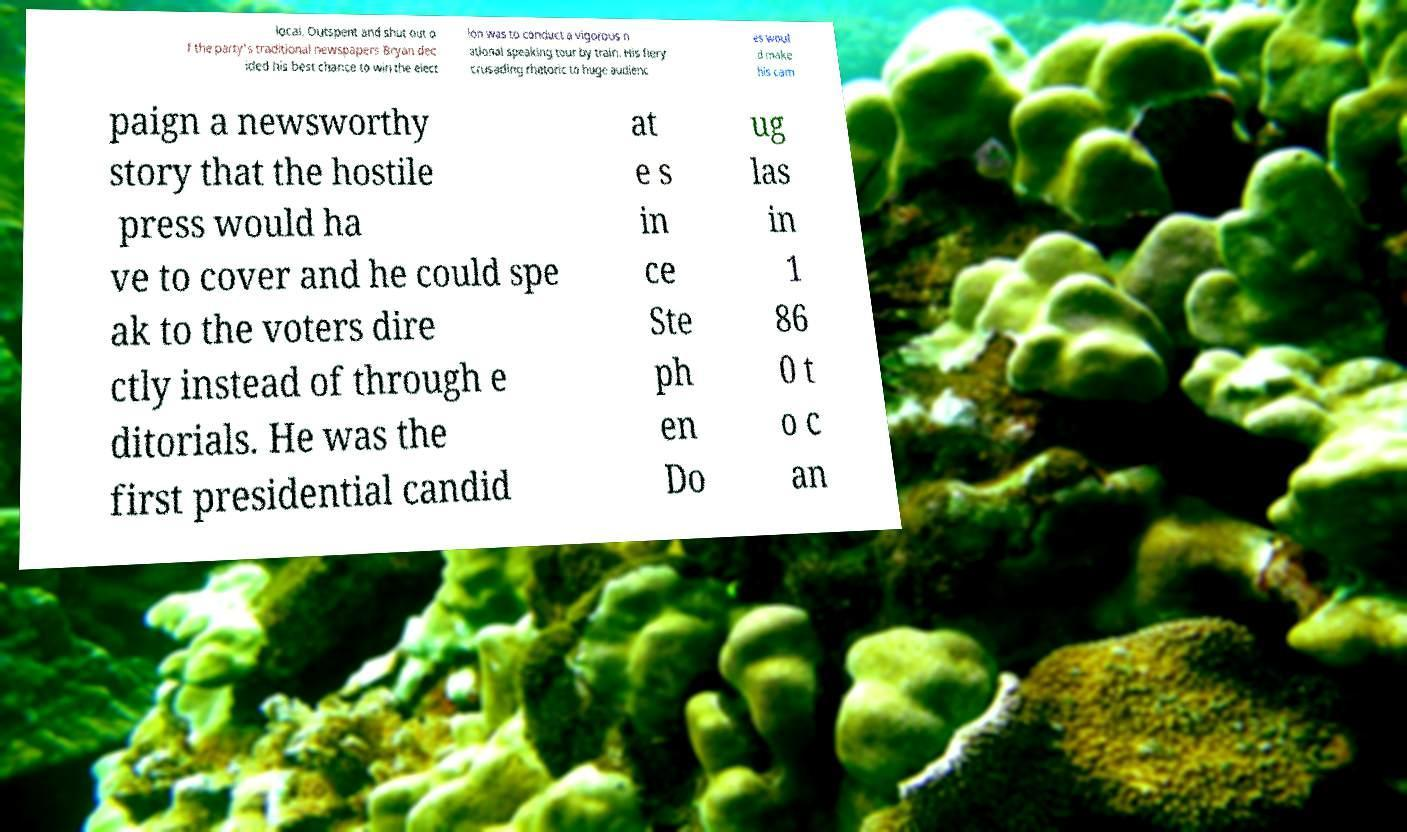Can you read and provide the text displayed in the image?This photo seems to have some interesting text. Can you extract and type it out for me? local. Outspent and shut out o f the party's traditional newspapers Bryan dec ided his best chance to win the elect ion was to conduct a vigorous n ational speaking tour by train. His fiery crusading rhetoric to huge audienc es woul d make his cam paign a newsworthy story that the hostile press would ha ve to cover and he could spe ak to the voters dire ctly instead of through e ditorials. He was the first presidential candid at e s in ce Ste ph en Do ug las in 1 86 0 t o c an 